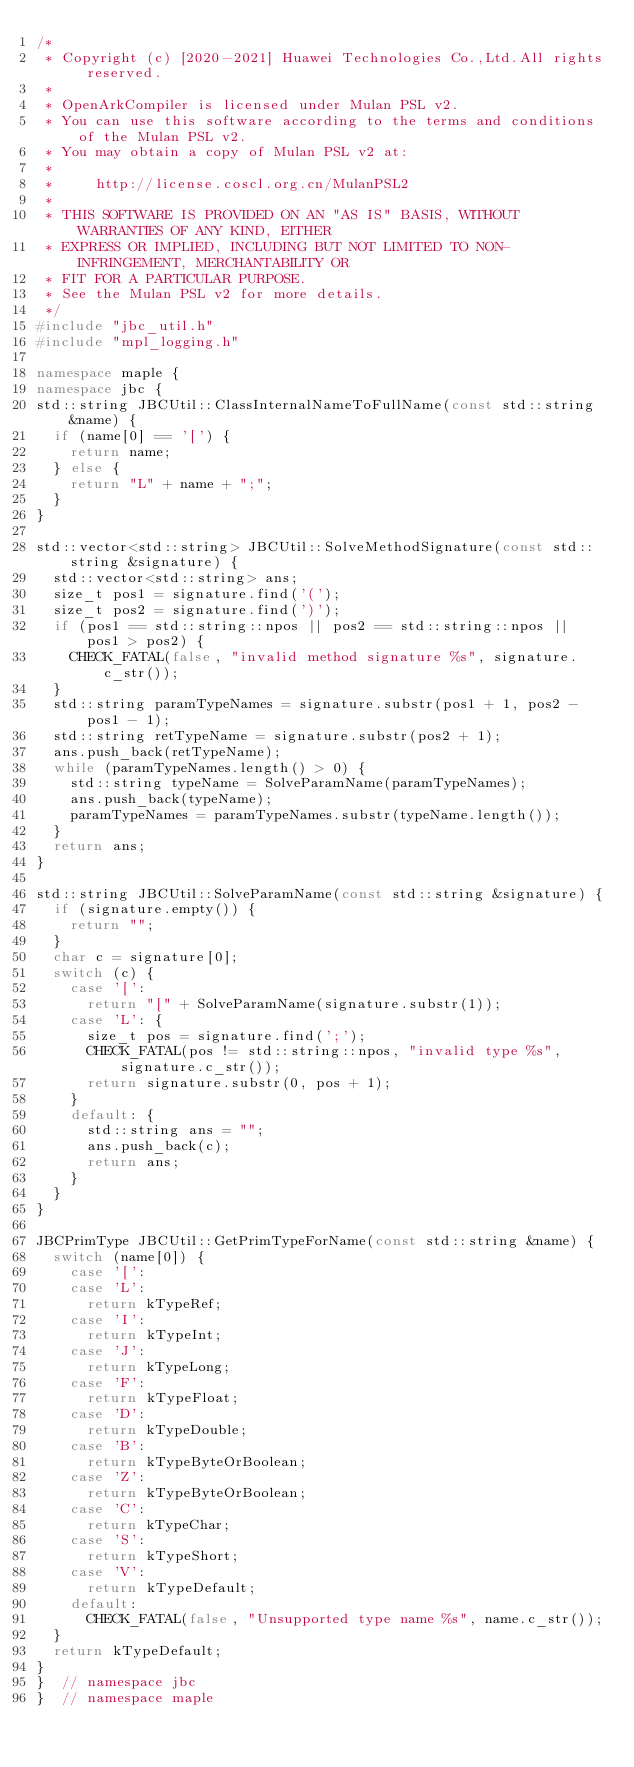Convert code to text. <code><loc_0><loc_0><loc_500><loc_500><_C++_>/*
 * Copyright (c) [2020-2021] Huawei Technologies Co.,Ltd.All rights reserved.
 *
 * OpenArkCompiler is licensed under Mulan PSL v2.
 * You can use this software according to the terms and conditions of the Mulan PSL v2.
 * You may obtain a copy of Mulan PSL v2 at:
 *
 *     http://license.coscl.org.cn/MulanPSL2
 *
 * THIS SOFTWARE IS PROVIDED ON AN "AS IS" BASIS, WITHOUT WARRANTIES OF ANY KIND, EITHER
 * EXPRESS OR IMPLIED, INCLUDING BUT NOT LIMITED TO NON-INFRINGEMENT, MERCHANTABILITY OR
 * FIT FOR A PARTICULAR PURPOSE.
 * See the Mulan PSL v2 for more details.
 */
#include "jbc_util.h"
#include "mpl_logging.h"

namespace maple {
namespace jbc {
std::string JBCUtil::ClassInternalNameToFullName(const std::string &name) {
  if (name[0] == '[') {
    return name;
  } else {
    return "L" + name + ";";
  }
}

std::vector<std::string> JBCUtil::SolveMethodSignature(const std::string &signature) {
  std::vector<std::string> ans;
  size_t pos1 = signature.find('(');
  size_t pos2 = signature.find(')');
  if (pos1 == std::string::npos || pos2 == std::string::npos || pos1 > pos2) {
    CHECK_FATAL(false, "invalid method signature %s", signature.c_str());
  }
  std::string paramTypeNames = signature.substr(pos1 + 1, pos2 - pos1 - 1);
  std::string retTypeName = signature.substr(pos2 + 1);
  ans.push_back(retTypeName);
  while (paramTypeNames.length() > 0) {
    std::string typeName = SolveParamName(paramTypeNames);
    ans.push_back(typeName);
    paramTypeNames = paramTypeNames.substr(typeName.length());
  }
  return ans;
}

std::string JBCUtil::SolveParamName(const std::string &signature) {
  if (signature.empty()) {
    return "";
  }
  char c = signature[0];
  switch (c) {
    case '[':
      return "[" + SolveParamName(signature.substr(1));
    case 'L': {
      size_t pos = signature.find(';');
      CHECK_FATAL(pos != std::string::npos, "invalid type %s", signature.c_str());
      return signature.substr(0, pos + 1);
    }
    default: {
      std::string ans = "";
      ans.push_back(c);
      return ans;
    }
  }
}

JBCPrimType JBCUtil::GetPrimTypeForName(const std::string &name) {
  switch (name[0]) {
    case '[':
    case 'L':
      return kTypeRef;
    case 'I':
      return kTypeInt;
    case 'J':
      return kTypeLong;
    case 'F':
      return kTypeFloat;
    case 'D':
      return kTypeDouble;
    case 'B':
      return kTypeByteOrBoolean;
    case 'Z':
      return kTypeByteOrBoolean;
    case 'C':
      return kTypeChar;
    case 'S':
      return kTypeShort;
    case 'V':
      return kTypeDefault;
    default:
      CHECK_FATAL(false, "Unsupported type name %s", name.c_str());
  }
  return kTypeDefault;
}
}  // namespace jbc
}  // namespace maple</code> 